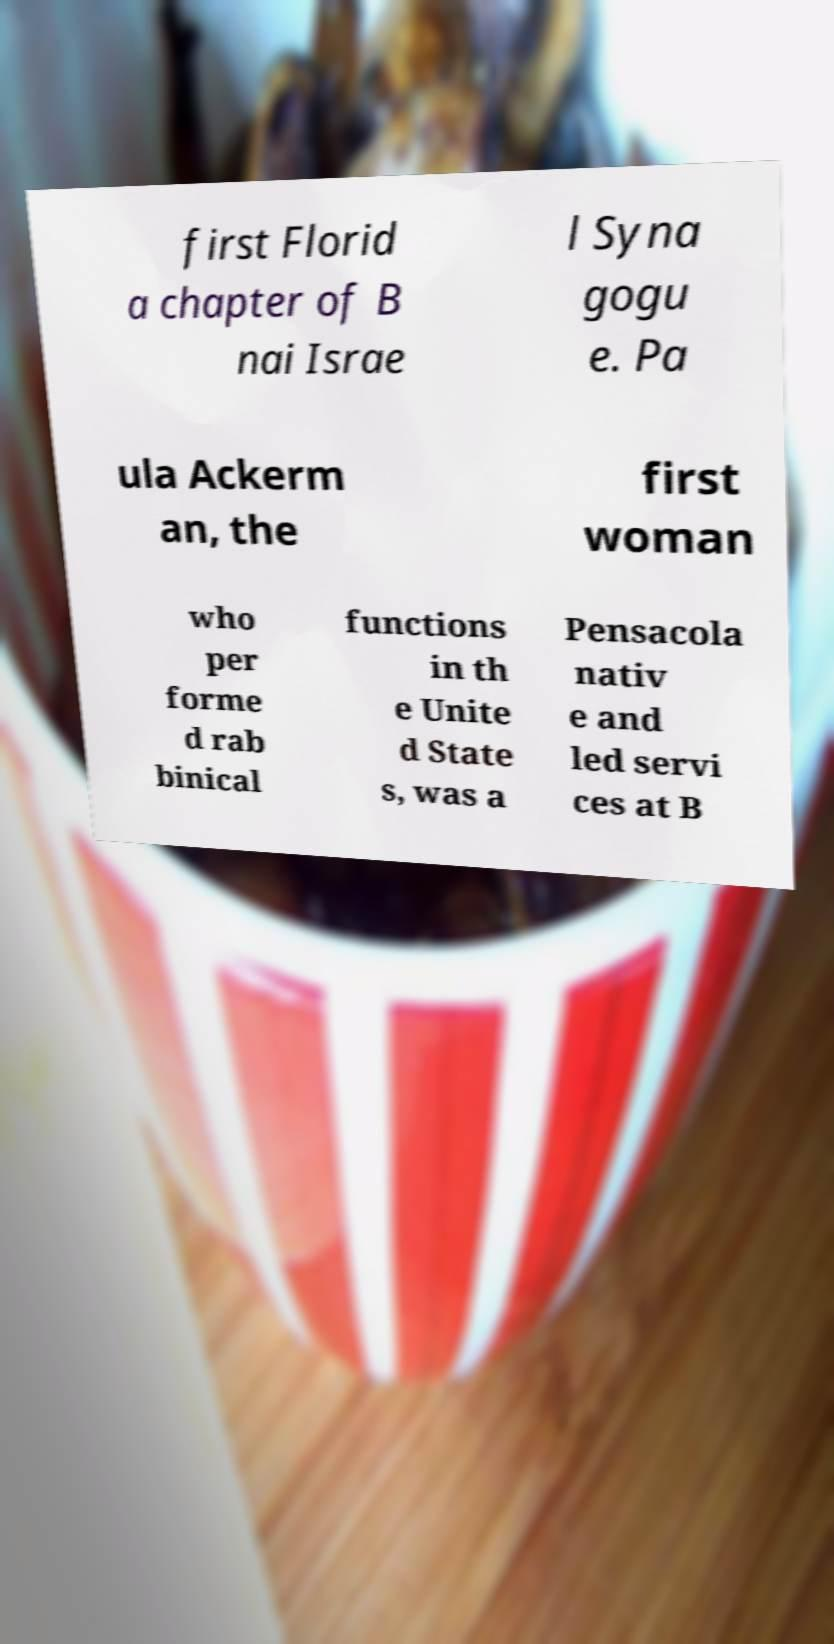Could you extract and type out the text from this image? first Florid a chapter of B nai Israe l Syna gogu e. Pa ula Ackerm an, the first woman who per forme d rab binical functions in th e Unite d State s, was a Pensacola nativ e and led servi ces at B 